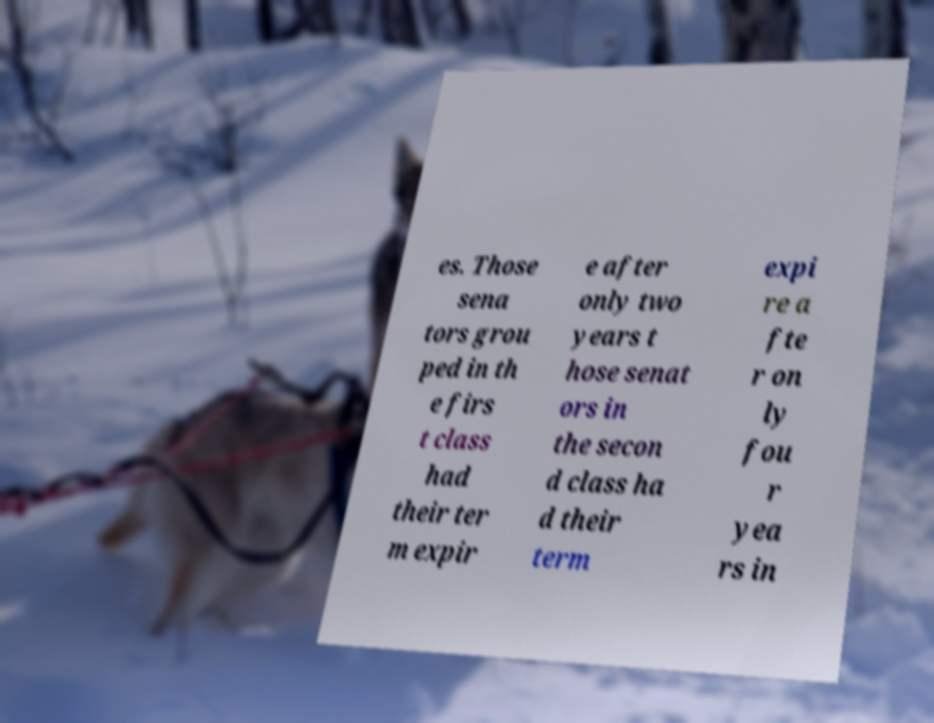There's text embedded in this image that I need extracted. Can you transcribe it verbatim? es. Those sena tors grou ped in th e firs t class had their ter m expir e after only two years t hose senat ors in the secon d class ha d their term expi re a fte r on ly fou r yea rs in 